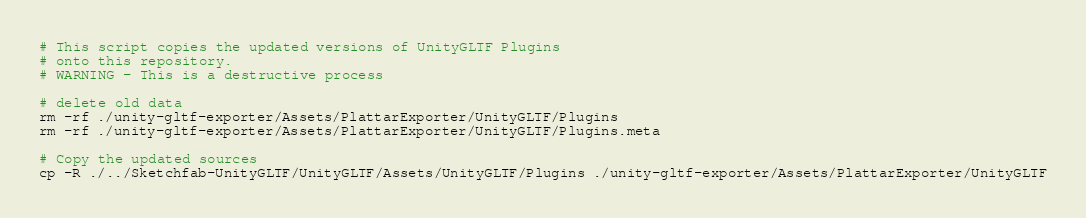<code> <loc_0><loc_0><loc_500><loc_500><_Bash_>
# This script copies the updated versions of UnityGLTF Plugins
# onto this repository.
# WARNING - This is a destructive process

# delete old data
rm -rf ./unity-gltf-exporter/Assets/PlattarExporter/UnityGLTF/Plugins
rm -rf ./unity-gltf-exporter/Assets/PlattarExporter/UnityGLTF/Plugins.meta

# Copy the updated sources
cp -R ./../Sketchfab-UnityGLTF/UnityGLTF/Assets/UnityGLTF/Plugins ./unity-gltf-exporter/Assets/PlattarExporter/UnityGLTF</code> 